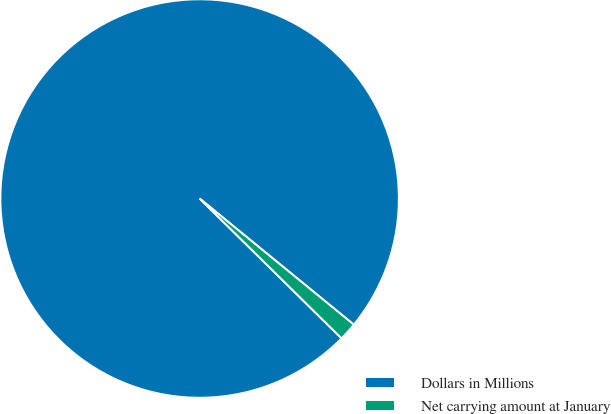<chart> <loc_0><loc_0><loc_500><loc_500><pie_chart><fcel>Dollars in Millions<fcel>Net carrying amount at January<nl><fcel>98.53%<fcel>1.47%<nl></chart> 